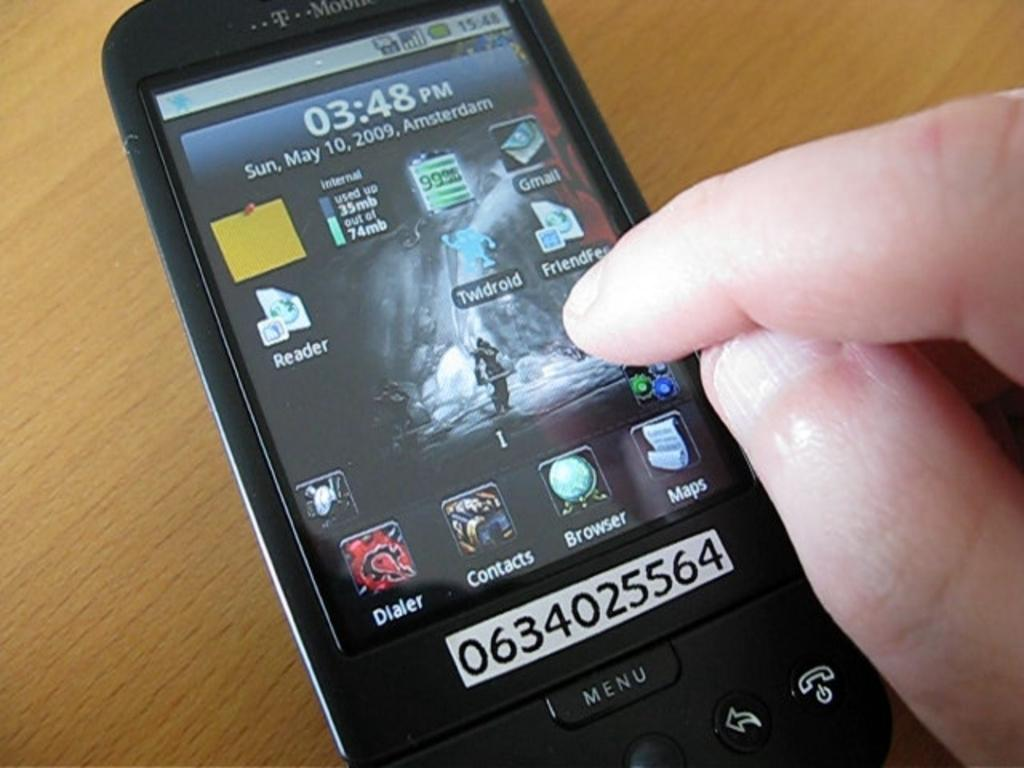<image>
Provide a brief description of the given image. As a cell phone sits on a table, a person goes to select the Twldroid app. 